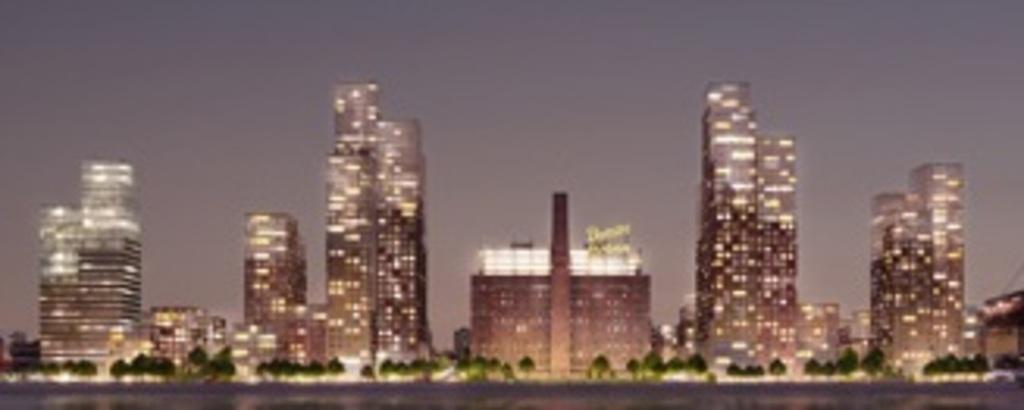What is located in the middle of the picture? There are buildings in the middle of the picture. What can be seen at the bottom of the picture? There are trees in the bottom of the picture. What is visible in the background of the picture? The sky is visible in the background of the picture. Is there an umbrella being used as a table in the image? There is no umbrella or table present in the image. What type of crime is being committed in the image? There is no crime or criminal activity depicted in the image. 